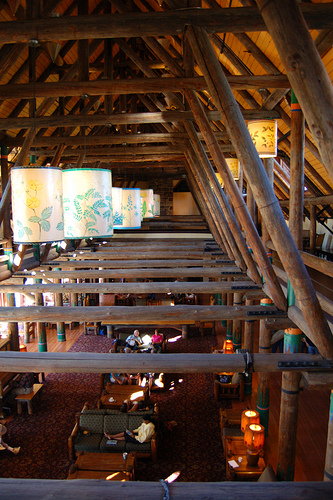<image>
Is there a lights behind the chair? No. The lights is not behind the chair. From this viewpoint, the lights appears to be positioned elsewhere in the scene. 